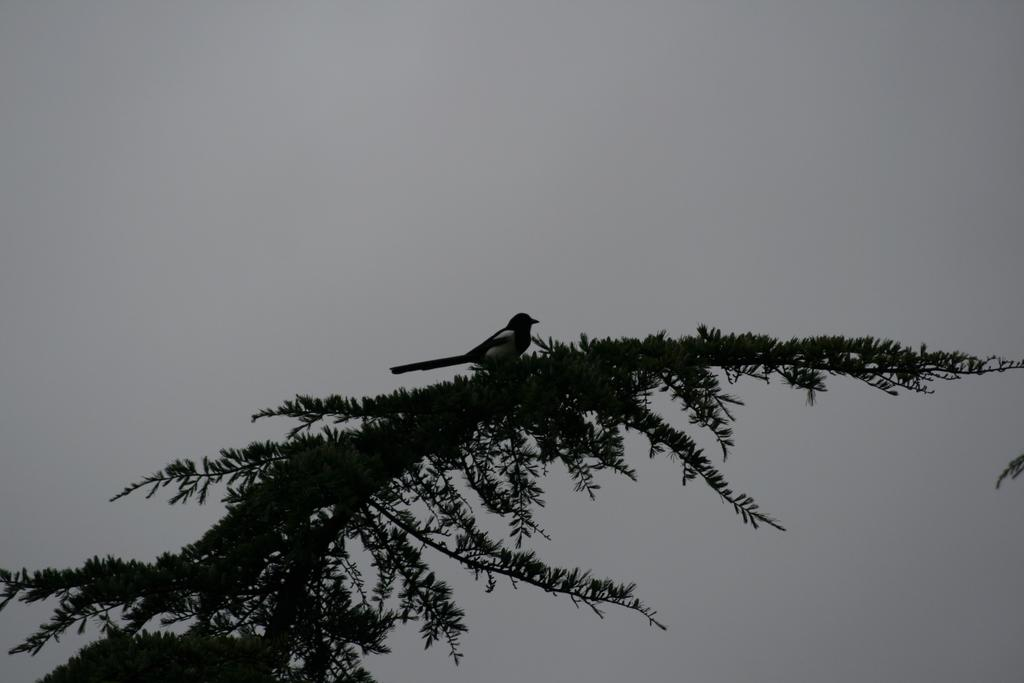What is the main subject of the image? There is a bird represented in the image. Where is the bird located in the image? The bird is on a plant. What type of badge is the bird wearing on its wing in the image? There is no badge present on the bird in the image. What type of bed is the bird resting on in the image? There is no bed present in the image; the bird is on a plant. 